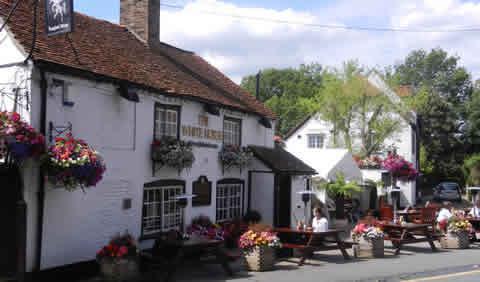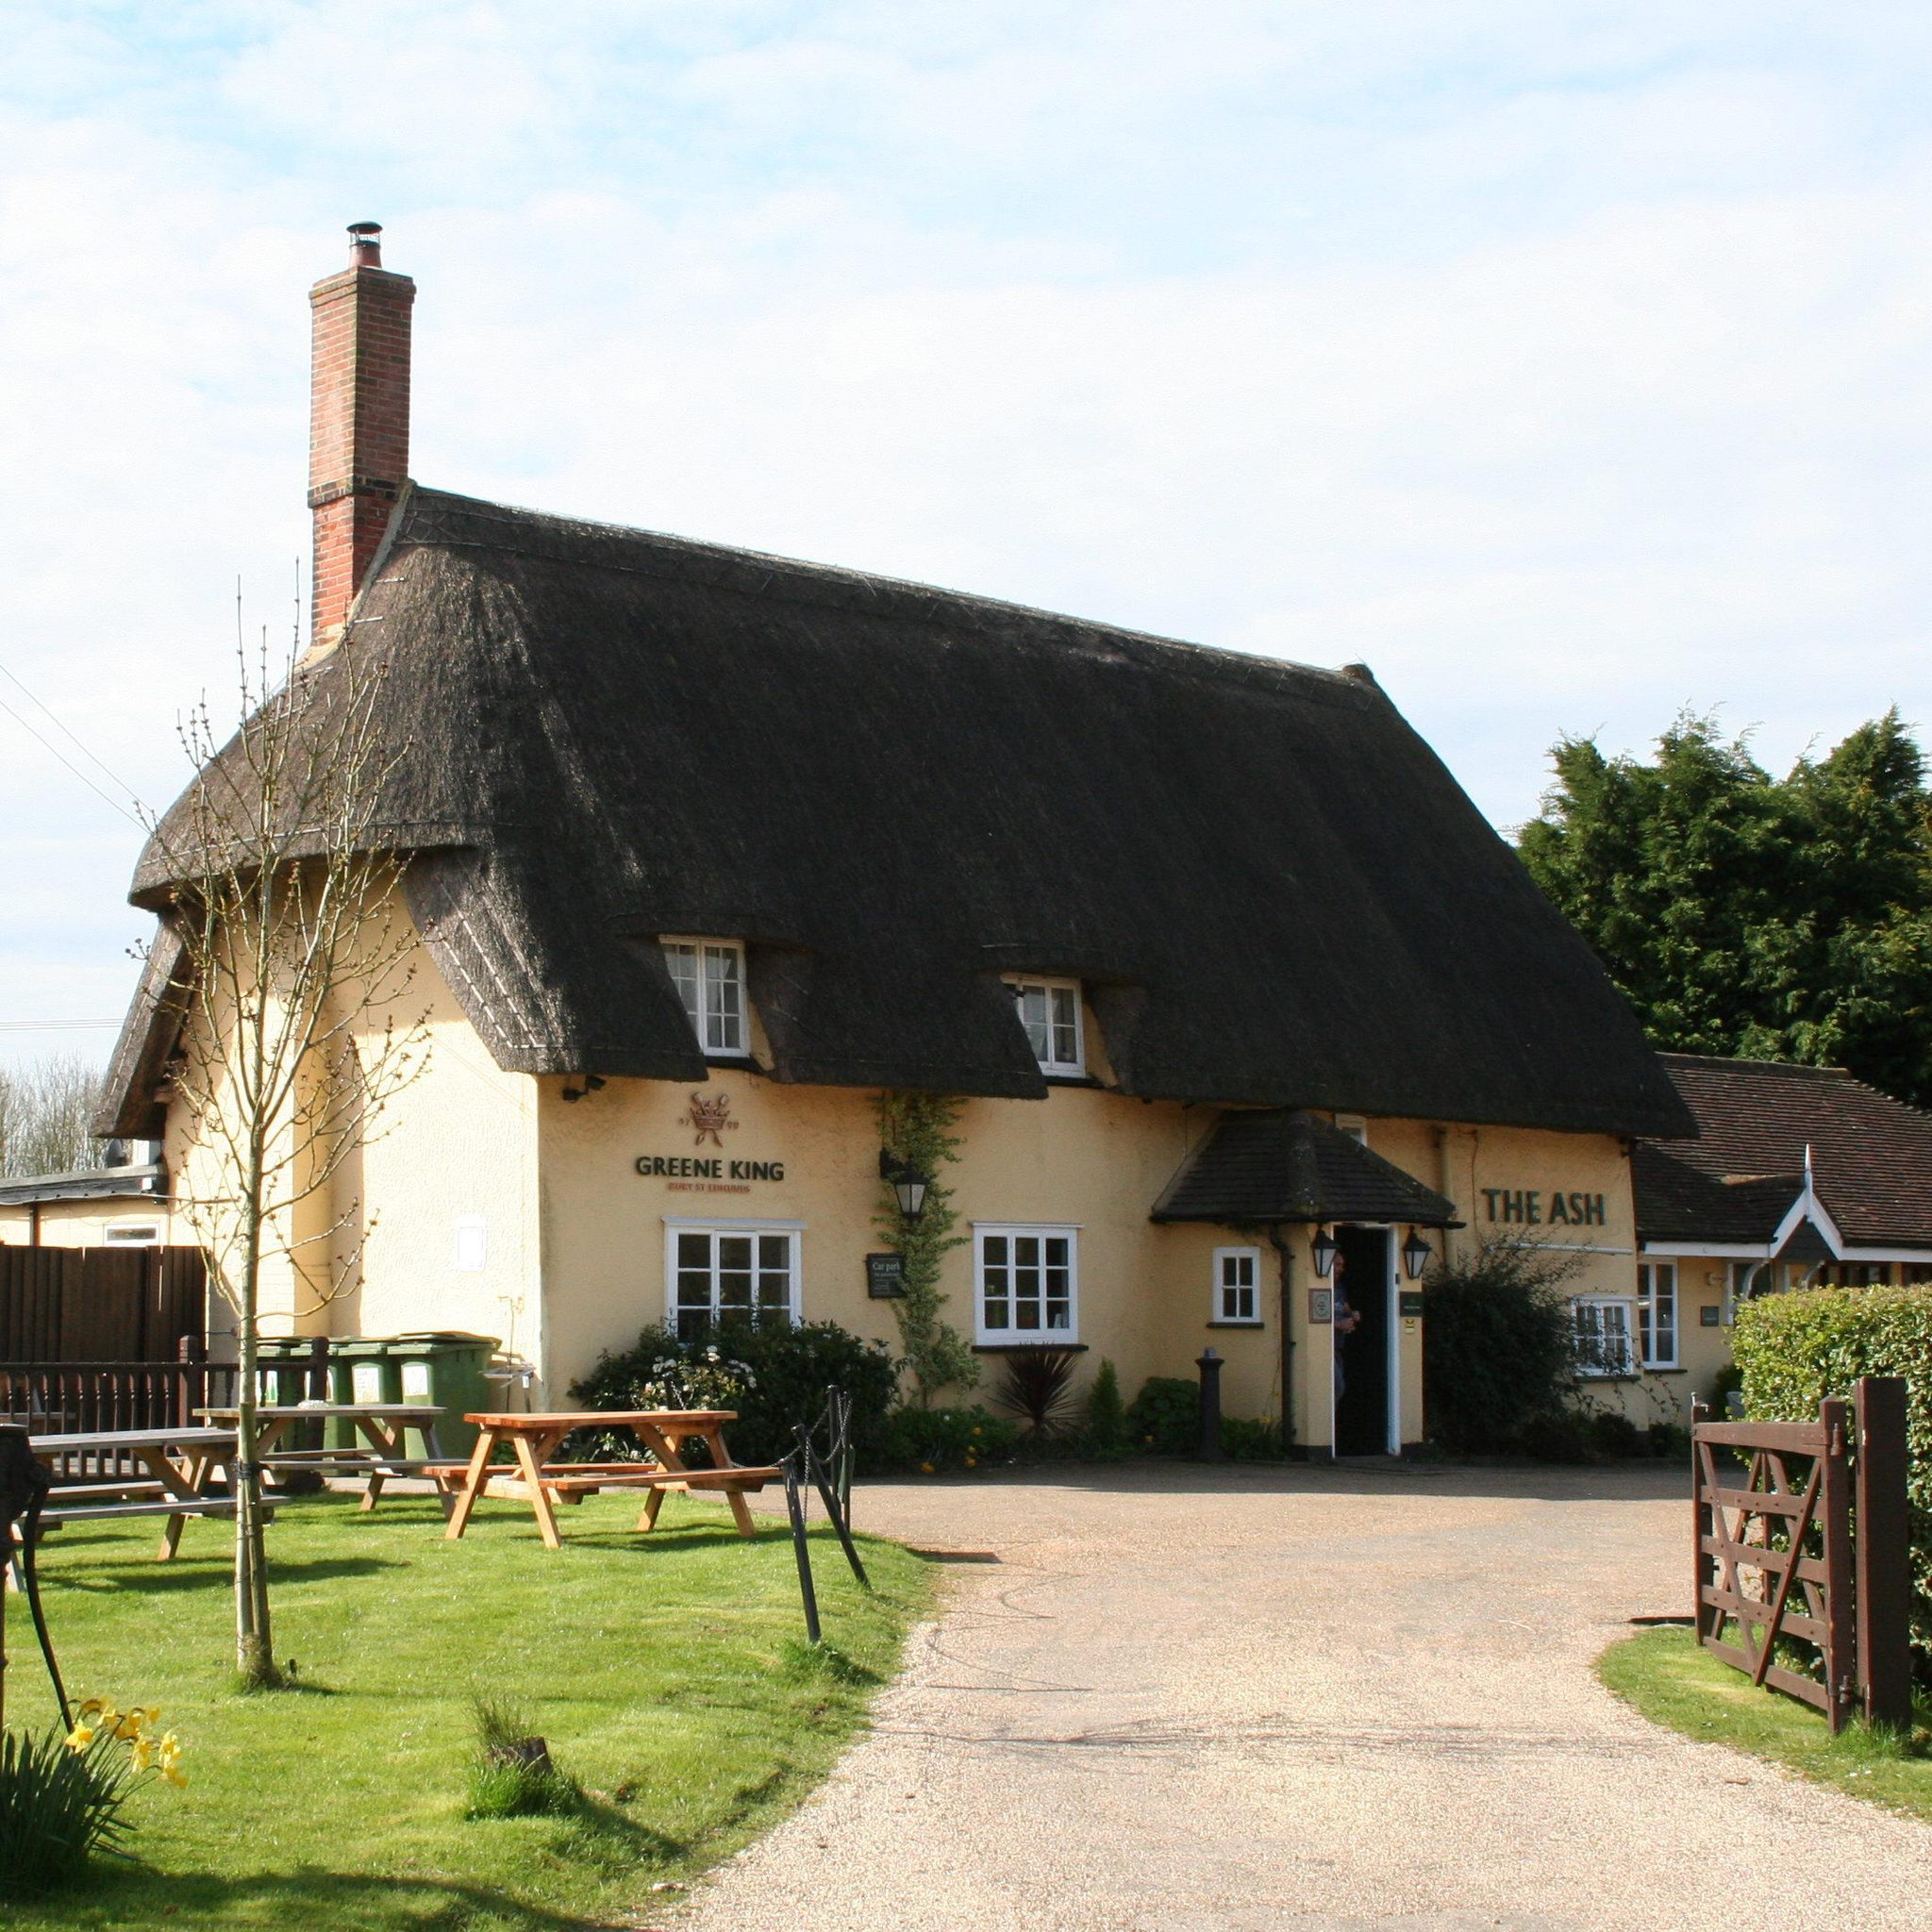The first image is the image on the left, the second image is the image on the right. Given the left and right images, does the statement "Each image shows a large building with a chimney sticking out of a non-shingle roof and multiple picnic tables situated near it." hold true? Answer yes or no. Yes. The first image is the image on the left, the second image is the image on the right. Given the left and right images, does the statement "A red chimney rises from a yellow building with a thatched roof." hold true? Answer yes or no. Yes. 